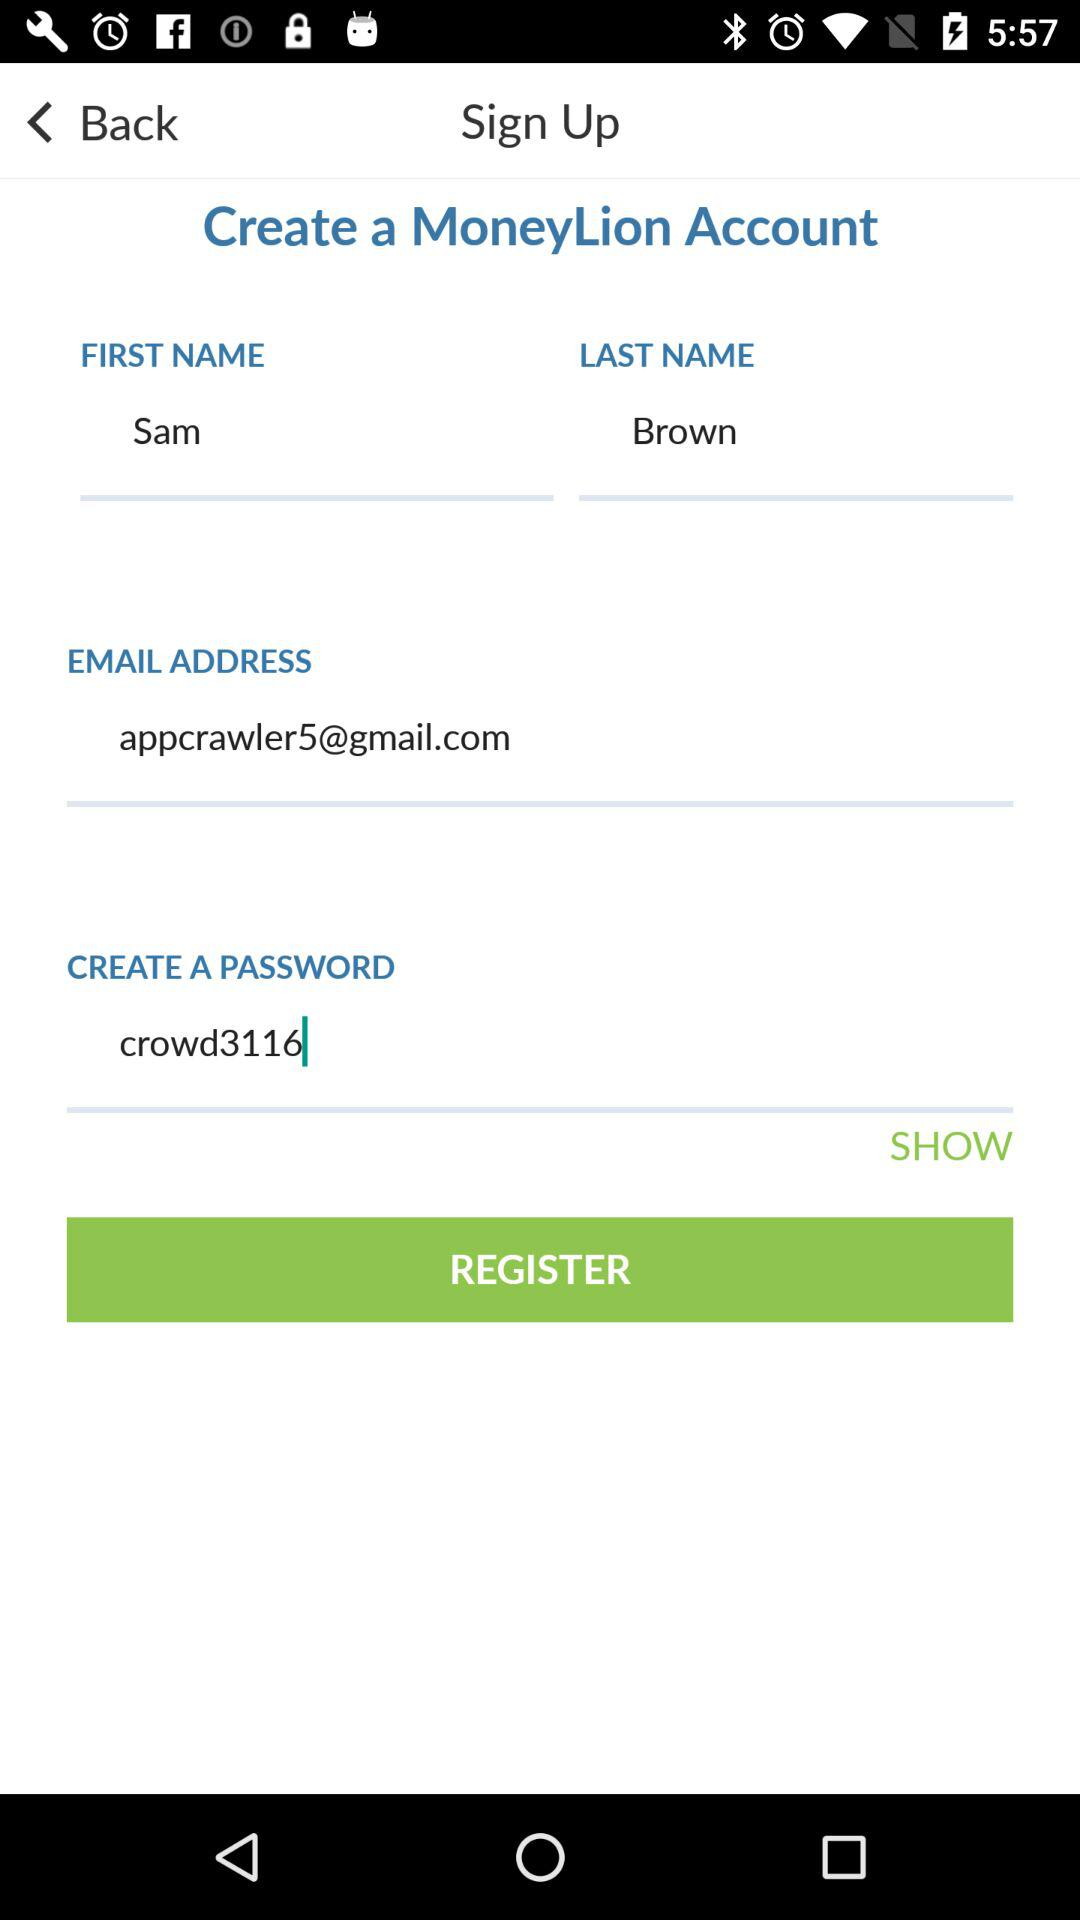What is the email address of the user? The email address of the user is appcrawler5@gmail.com. 